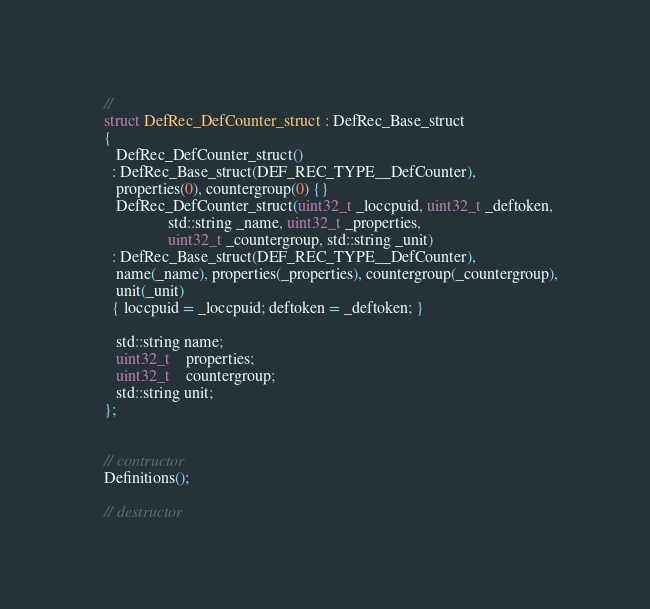<code> <loc_0><loc_0><loc_500><loc_500><_C_>   //
   struct DefRec_DefCounter_struct : DefRec_Base_struct
   {
      DefRec_DefCounter_struct()
	 : DefRec_Base_struct(DEF_REC_TYPE__DefCounter),
      properties(0), countergroup(0) {}
      DefRec_DefCounter_struct(uint32_t _loccpuid, uint32_t _deftoken,
			       std::string _name, uint32_t _properties,
			       uint32_t _countergroup, std::string _unit)
	 : DefRec_Base_struct(DEF_REC_TYPE__DefCounter),
      name(_name), properties(_properties), countergroup(_countergroup),
      unit(_unit)
	 { loccpuid = _loccpuid; deftoken = _deftoken; }
      
      std::string name;
      uint32_t    properties;
      uint32_t    countergroup;
      std::string unit;
   };


   // contructor
   Definitions();

   // destructor</code> 